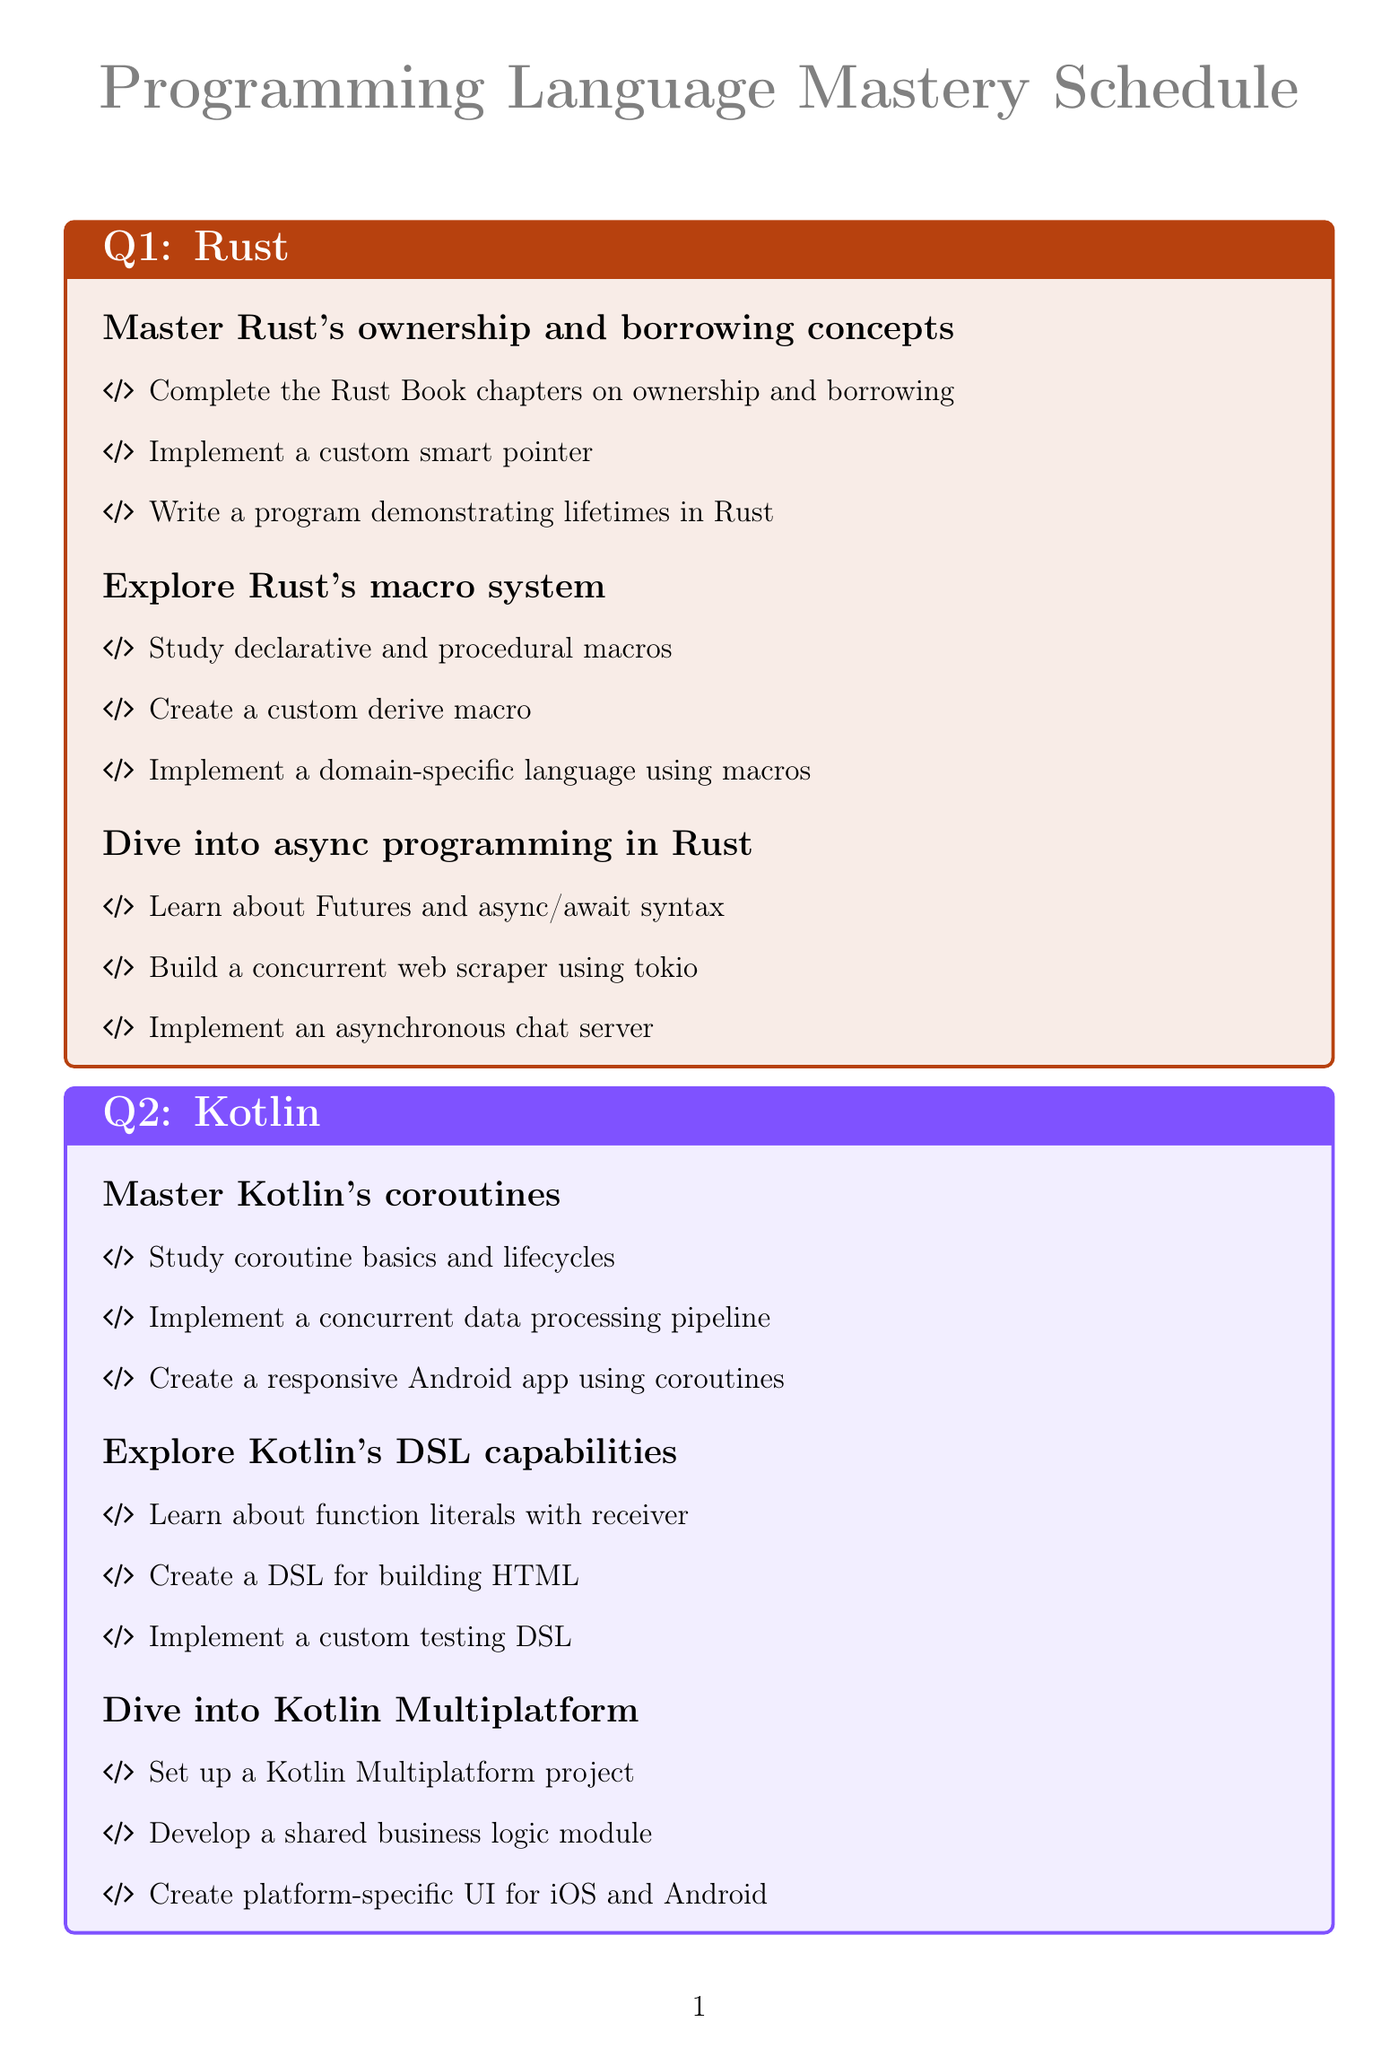What is the primary focus language for Q1? The primary focus language for Q1 is stated in the document, which is Rust.
Answer: Rust How many goals are there for Q2? The number of goals is explicitly listed in the Q2 section of the document. There are three goals for Q2.
Answer: 3 What is one task under the goal "Master Go's concurrency patterns"? This task can be identified in the list under the corresponding goal in the Q4 section of the document.
Answer: Study goroutines and channels Which programming language is focused on in Q3? The programming language for Q3 is mentioned in the document.
Answer: TypeScript What is the last task listed under the goal "Dive into Go's reflection capabilities"? This can be found by looking at the listed tasks under the mentioned goal in the Q4 section.
Answer: Create a dependency injection container What concept is the focus of the first goal in Q1? This information is provided in the Q1 section of the document and refers to Rust's features.
Answer: Ownership and borrowing How many tasks are there under the goal "Explore Kotlin's DSL capabilities"? The exact number of tasks can be counted from the corresponding section in Q2.
Answer: 3 Which quarterly goal involves creating a responsive Android app? This can be found by examining the tasks under the goal related to Kotlin in Q2.
Answer: Master Kotlin's coroutines 